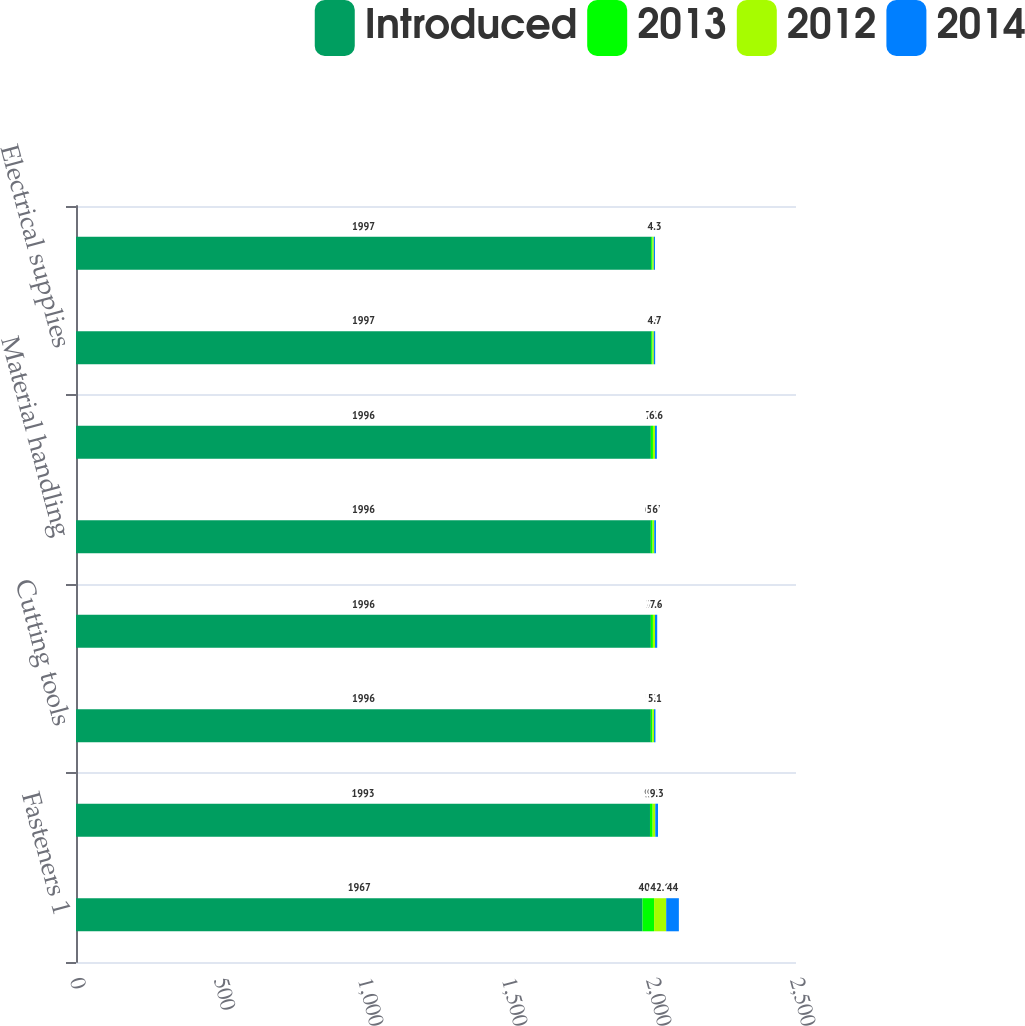Convert chart. <chart><loc_0><loc_0><loc_500><loc_500><stacked_bar_chart><ecel><fcel>Fasteners 1<fcel>Tools<fcel>Cutting tools<fcel>Hydraulics & pneumatics<fcel>Material handling<fcel>Janitorial supplies<fcel>Electrical supplies<fcel>Welding supplies<nl><fcel>Introduced<fcel>1967<fcel>1993<fcel>1996<fcel>1996<fcel>1996<fcel>1996<fcel>1997<fcel>1997<nl><fcel>2013<fcel>40.2<fcel>9.3<fcel>5.5<fcel>7.2<fcel>6.1<fcel>7.3<fcel>4.7<fcel>4.7<nl><fcel>2012<fcel>42.1<fcel>9.2<fcel>5.4<fcel>7.3<fcel>5.7<fcel>7<fcel>4.6<fcel>4.5<nl><fcel>2014<fcel>44<fcel>9.3<fcel>5.1<fcel>7.6<fcel>6<fcel>6.6<fcel>4.7<fcel>4.3<nl></chart> 